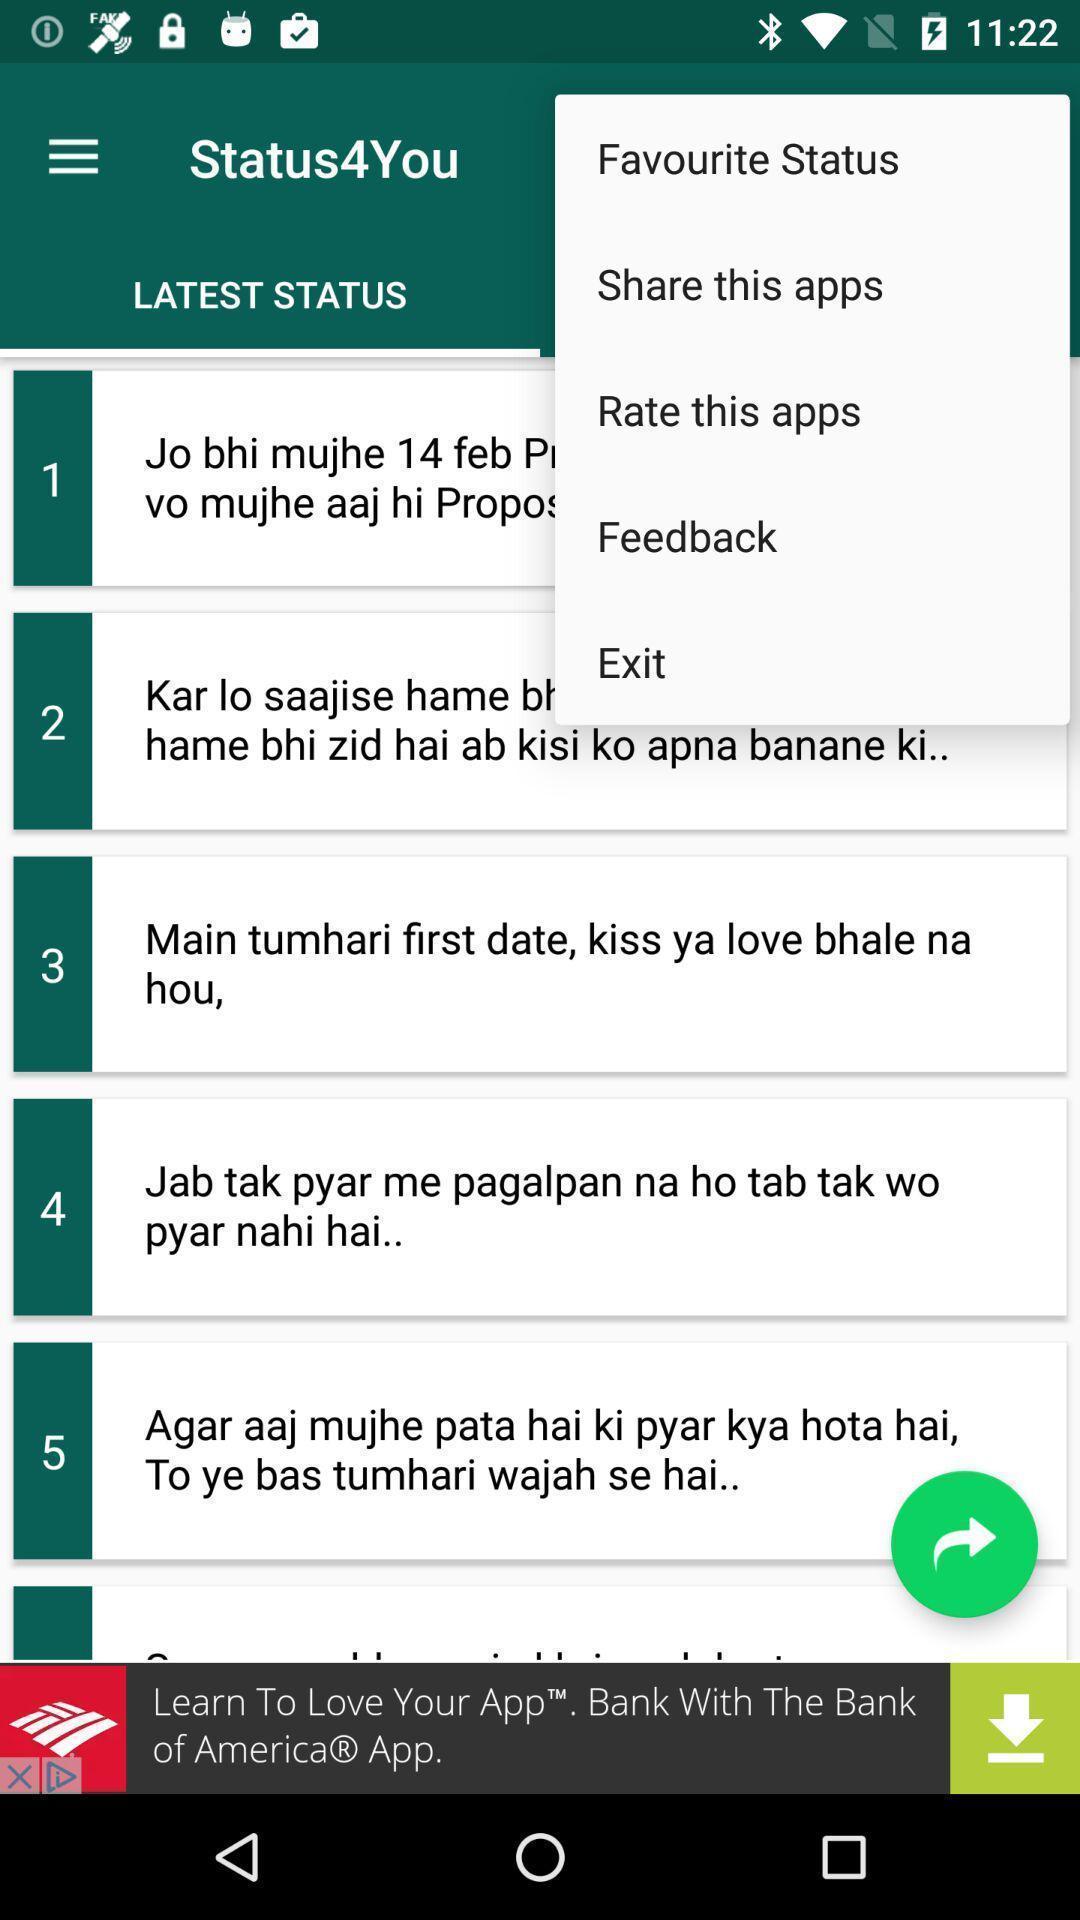Tell me about the visual elements in this screen capture. Screen shows status page with various options. 